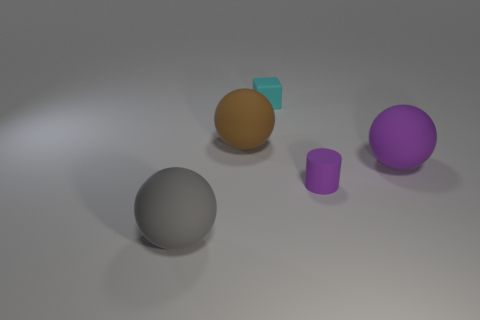There is a big object that is in front of the tiny object right of the cyan thing that is to the left of the small purple matte thing; what is its material?
Keep it short and to the point. Rubber. What size is the rubber ball that is both on the right side of the gray rubber ball and left of the purple rubber cylinder?
Provide a short and direct response. Large. Is the shape of the tiny cyan rubber object the same as the small purple thing?
Make the answer very short. No. What shape is the cyan object that is made of the same material as the small purple object?
Your answer should be compact. Cube. What number of small objects are green cylinders or rubber blocks?
Provide a succinct answer. 1. There is a tiny thing in front of the cyan rubber cube; are there any large things that are in front of it?
Ensure brevity in your answer.  Yes. Are any small yellow cylinders visible?
Ensure brevity in your answer.  No. There is a big sphere that is behind the purple rubber thing behind the tiny purple object; what is its color?
Make the answer very short. Brown. What material is the big purple object that is the same shape as the brown thing?
Keep it short and to the point. Rubber. How many matte cylinders are the same size as the brown ball?
Your answer should be compact. 0. 